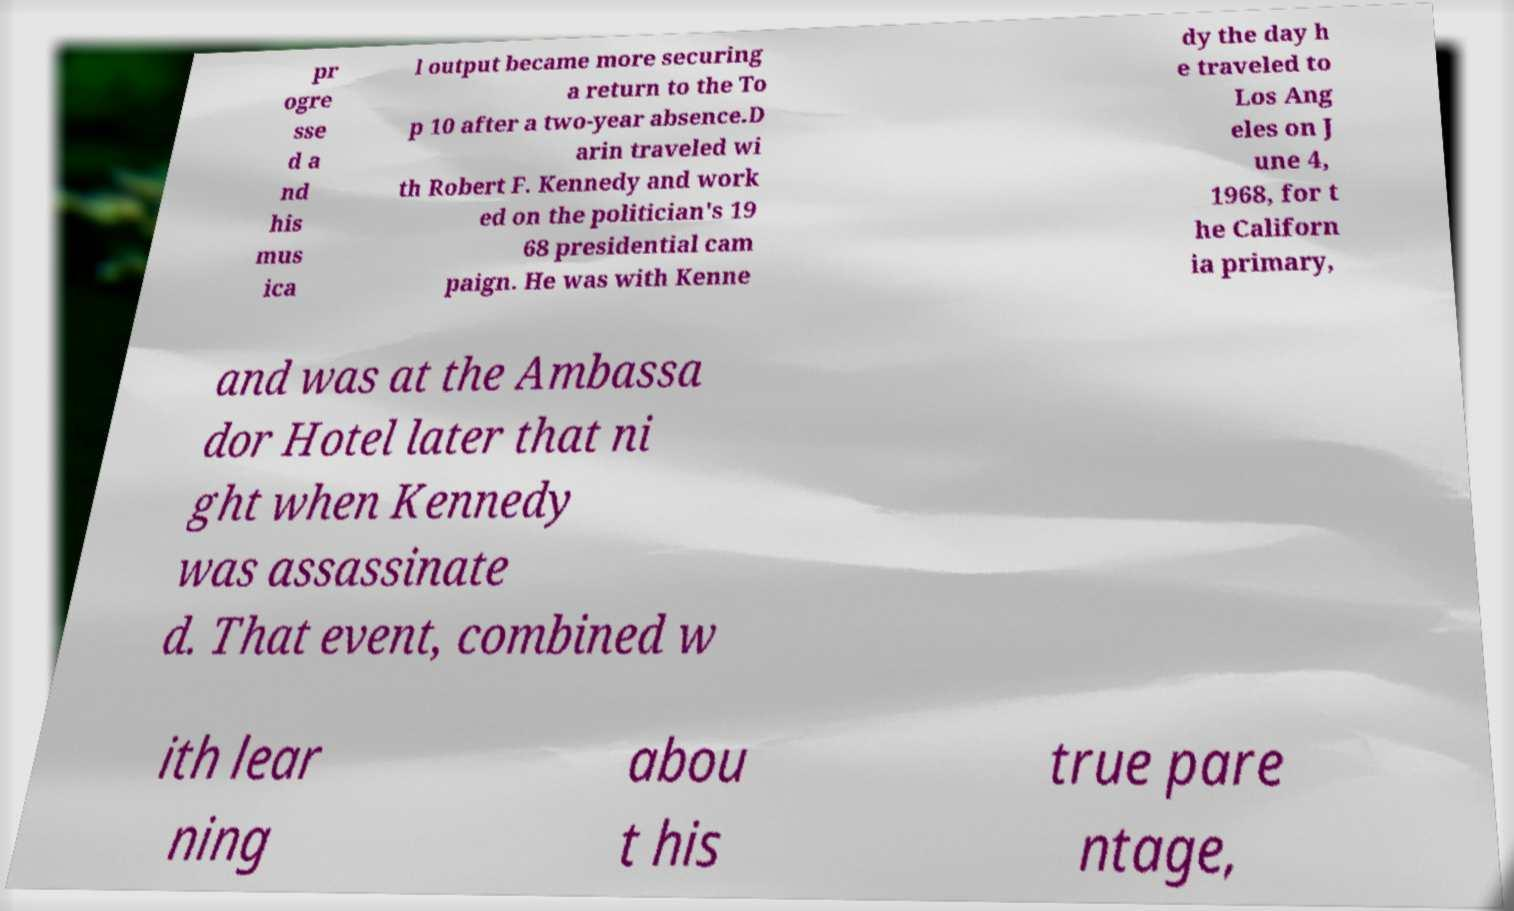Could you assist in decoding the text presented in this image and type it out clearly? pr ogre sse d a nd his mus ica l output became more securing a return to the To p 10 after a two-year absence.D arin traveled wi th Robert F. Kennedy and work ed on the politician's 19 68 presidential cam paign. He was with Kenne dy the day h e traveled to Los Ang eles on J une 4, 1968, for t he Californ ia primary, and was at the Ambassa dor Hotel later that ni ght when Kennedy was assassinate d. That event, combined w ith lear ning abou t his true pare ntage, 